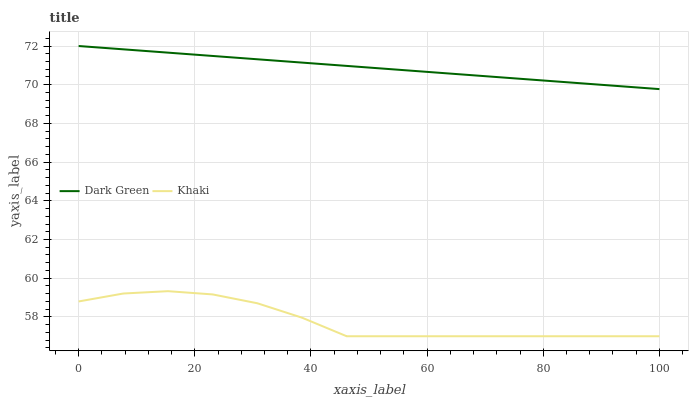Does Khaki have the minimum area under the curve?
Answer yes or no. Yes. Does Dark Green have the maximum area under the curve?
Answer yes or no. Yes. Does Dark Green have the minimum area under the curve?
Answer yes or no. No. Is Dark Green the smoothest?
Answer yes or no. Yes. Is Khaki the roughest?
Answer yes or no. Yes. Is Dark Green the roughest?
Answer yes or no. No. Does Khaki have the lowest value?
Answer yes or no. Yes. Does Dark Green have the lowest value?
Answer yes or no. No. Does Dark Green have the highest value?
Answer yes or no. Yes. Is Khaki less than Dark Green?
Answer yes or no. Yes. Is Dark Green greater than Khaki?
Answer yes or no. Yes. Does Khaki intersect Dark Green?
Answer yes or no. No. 